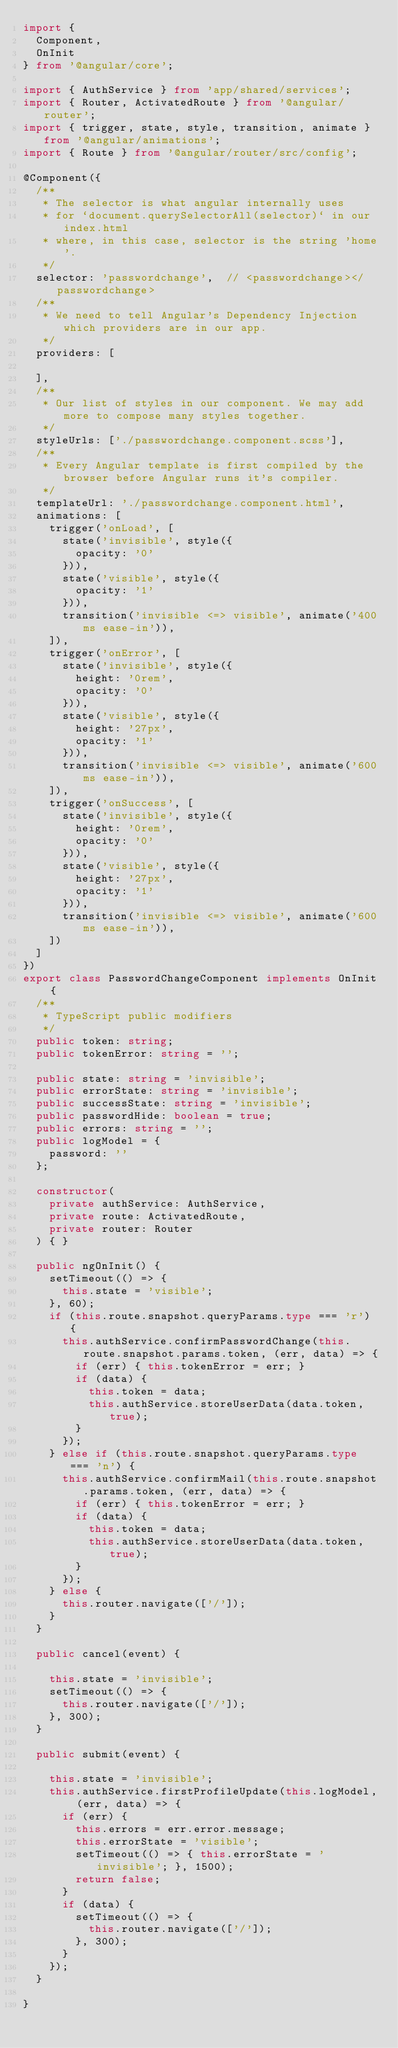<code> <loc_0><loc_0><loc_500><loc_500><_TypeScript_>import {
  Component,
  OnInit
} from '@angular/core';

import { AuthService } from 'app/shared/services';
import { Router, ActivatedRoute } from '@angular/router';
import { trigger, state, style, transition, animate } from '@angular/animations';
import { Route } from '@angular/router/src/config';

@Component({
  /**
   * The selector is what angular internally uses
   * for `document.querySelectorAll(selector)` in our index.html
   * where, in this case, selector is the string 'home'.
   */
  selector: 'passwordchange',  // <passwordchange></passwordchange>
  /**
   * We need to tell Angular's Dependency Injection which providers are in our app.
   */
  providers: [

  ],
  /**
   * Our list of styles in our component. We may add more to compose many styles together.
   */
  styleUrls: ['./passwordchange.component.scss'],
  /**
   * Every Angular template is first compiled by the browser before Angular runs it's compiler.
   */
  templateUrl: './passwordchange.component.html',
  animations: [
    trigger('onLoad', [
      state('invisible', style({
        opacity: '0'
      })),
      state('visible', style({
        opacity: '1'
      })),
      transition('invisible <=> visible', animate('400ms ease-in')),
    ]),
    trigger('onError', [
      state('invisible', style({
        height: '0rem',
        opacity: '0'
      })),
      state('visible', style({
        height: '27px',
        opacity: '1'
      })),
      transition('invisible <=> visible', animate('600ms ease-in')),
    ]),
    trigger('onSuccess', [
      state('invisible', style({
        height: '0rem',
        opacity: '0'
      })),
      state('visible', style({
        height: '27px',
        opacity: '1'
      })),
      transition('invisible <=> visible', animate('600ms ease-in')),
    ])
  ]
})
export class PasswordChangeComponent implements OnInit {
  /**
   * TypeScript public modifiers
   */
  public token: string;
  public tokenError: string = '';

  public state: string = 'invisible';
  public errorState: string = 'invisible';
  public successState: string = 'invisible';
  public passwordHide: boolean = true;
  public errors: string = '';
  public logModel = {
    password: ''
  };

  constructor(
    private authService: AuthService,
    private route: ActivatedRoute,
    private router: Router
  ) { }

  public ngOnInit() {
    setTimeout(() => {
      this.state = 'visible';
    }, 60);
    if (this.route.snapshot.queryParams.type === 'r') {
      this.authService.confirmPasswordChange(this.route.snapshot.params.token, (err, data) => {
        if (err) { this.tokenError = err; }
        if (data) {
          this.token = data;
          this.authService.storeUserData(data.token, true);
        }
      });
    } else if (this.route.snapshot.queryParams.type === 'n') {
      this.authService.confirmMail(this.route.snapshot.params.token, (err, data) => {
        if (err) { this.tokenError = err; }
        if (data) {
          this.token = data;
          this.authService.storeUserData(data.token, true);
        }
      });
    } else {
      this.router.navigate(['/']);
    }
  }

  public cancel(event) {

    this.state = 'invisible';
    setTimeout(() => {
      this.router.navigate(['/']);
    }, 300);
  }

  public submit(event) {

    this.state = 'invisible';
    this.authService.firstProfileUpdate(this.logModel, (err, data) => {
      if (err) {
        this.errors = err.error.message;
        this.errorState = 'visible';
        setTimeout(() => { this.errorState = 'invisible'; }, 1500);
        return false;
      }
      if (data) {
        setTimeout(() => {
          this.router.navigate(['/']);
        }, 300);
      }
    });
  }

}
</code> 